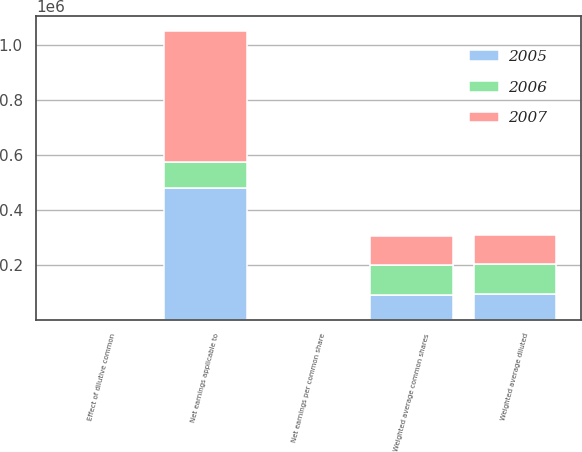<chart> <loc_0><loc_0><loc_500><loc_500><stacked_bar_chart><ecel><fcel>Net earnings applicable to<fcel>Weighted average common shares<fcel>Net earnings per common share<fcel>Effect of dilutive common<fcel>Weighted average diluted<nl><fcel>2007<fcel>479422<fcel>107365<fcel>4.47<fcel>1158<fcel>108523<nl><fcel>2006<fcel>92090.5<fcel>106057<fcel>5.46<fcel>1971<fcel>108028<nl><fcel>2005<fcel>480121<fcel>91187<fcel>5.27<fcel>1807<fcel>92994<nl></chart> 